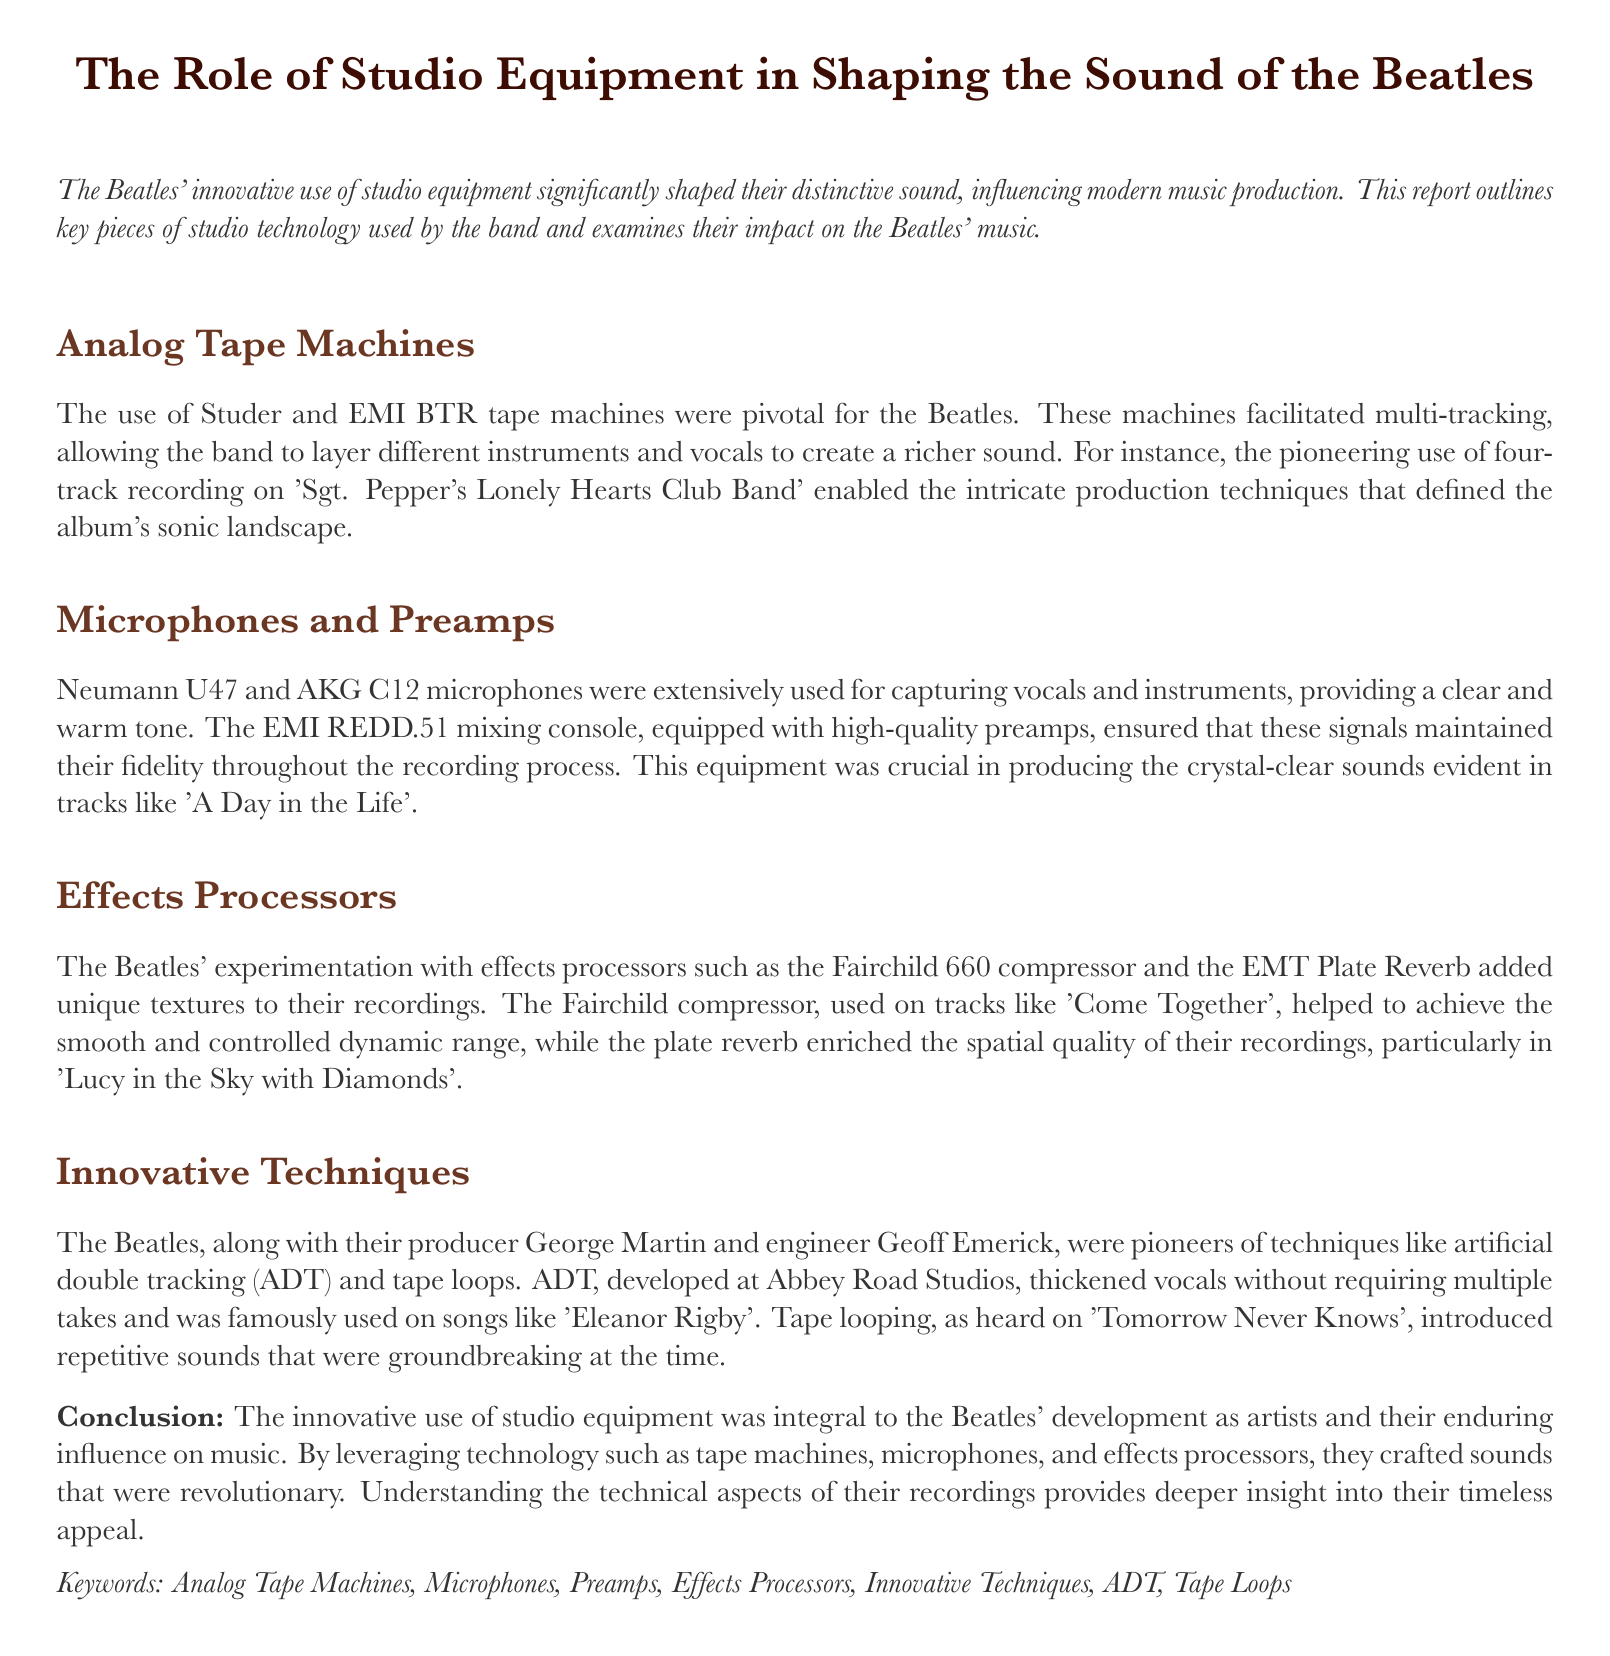What type of tape machines were pivotal for the Beatles? The document specifies that Studer and EMI BTR tape machines were essential in shaping the Beatles' sound.
Answer: Studer and EMI BTR Which mic was extensively used for vocals and instruments? The Neumann U47 is mentioned as a key microphone used for capturing vocals and instruments.
Answer: Neumann U47 What innovative technique was famously used on 'Eleanor Rigby'? The document states that artificial double tracking (ADT) was used prominently on the song 'Eleanor Rigby'.
Answer: ADT What effect processor was used to achieve smooth dynamic range on 'Come Together'? The Fairchild 660 compressor was specifically highlighted as being used for its effect on the track 'Come Together'.
Answer: Fairchild 660 Which album featured the pioneering use of four-track recording? The report mentions 'Sgt. Pepper's Lonely Hearts Club Band' as the album that utilized four-track recording.
Answer: Sgt. Pepper's Lonely Hearts Club Band What is the primary focus of this lab report? The document's introduction states that it outlines the role of studio equipment in shaping the Beatles' sound.
Answer: Studio equipment Which effect enriched the spatial quality in 'Lucy in the Sky with Diamonds'? The plate reverb is identified as the effect that added spatial quality to the recording of 'Lucy in the Sky with Diamonds'.
Answer: Plate reverb Who were the main figures behind the innovative techniques used by the Beatles? The report credits George Martin and Geoff Emerick as the key figures behind the innovative recording techniques.
Answer: George Martin and Geoff Emerick 